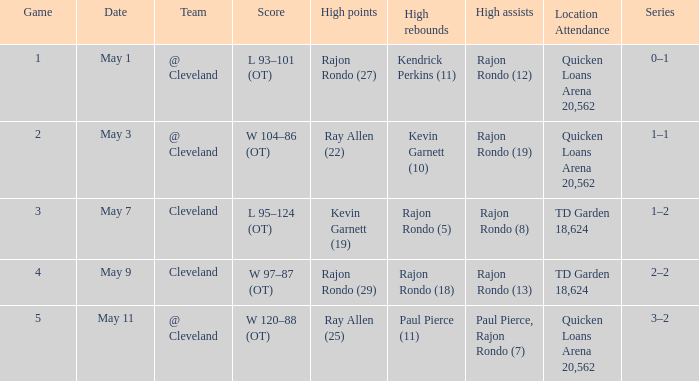On may 3, where is the team's game taking place? @ Cleveland. 